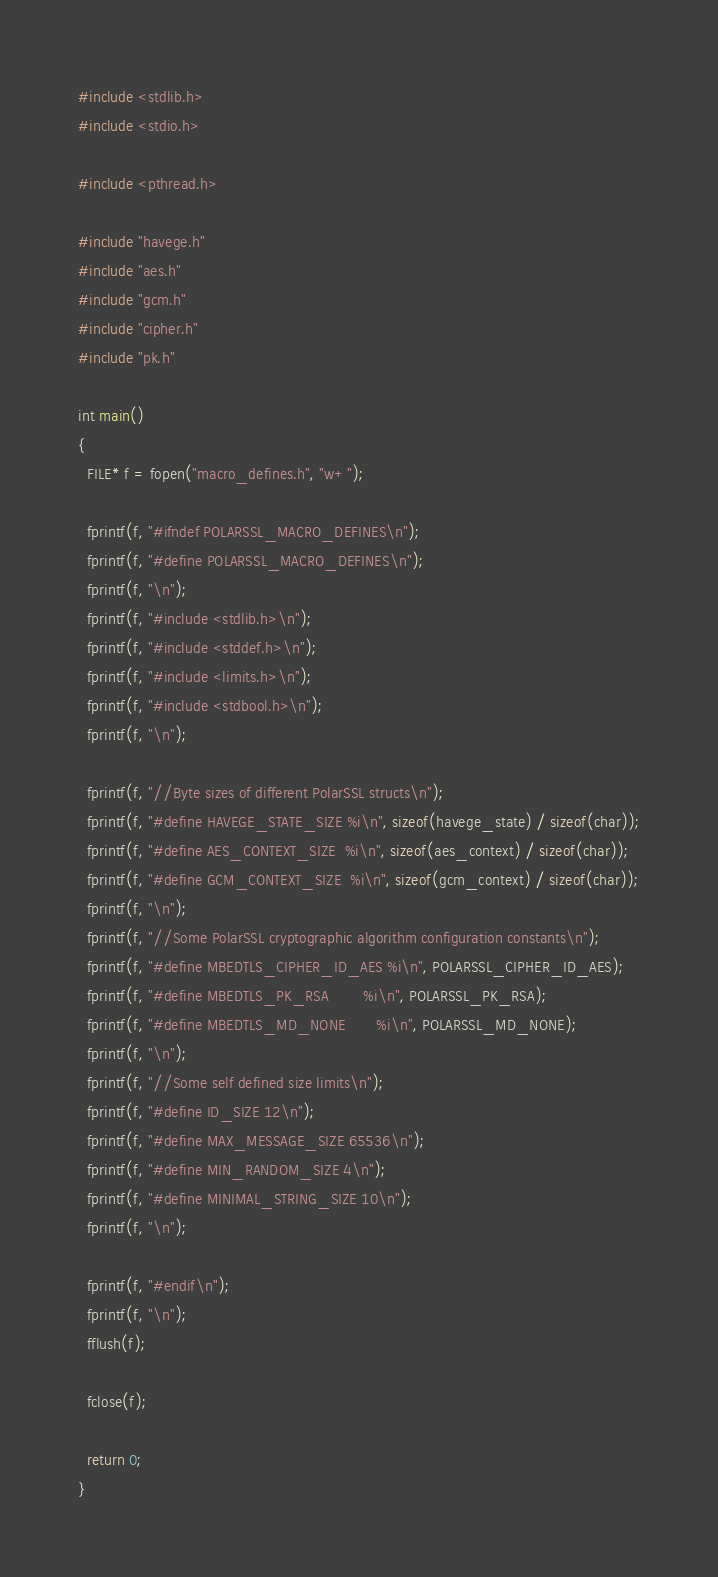Convert code to text. <code><loc_0><loc_0><loc_500><loc_500><_C_>#include <stdlib.h>
#include <stdio.h>

#include <pthread.h>

#include "havege.h"
#include "aes.h"
#include "gcm.h"
#include "cipher.h"
#include "pk.h"

int main()
{
  FILE* f = fopen("macro_defines.h", "w+");
  
  fprintf(f, "#ifndef POLARSSL_MACRO_DEFINES\n");
  fprintf(f, "#define POLARSSL_MACRO_DEFINES\n");
  fprintf(f, "\n");
  fprintf(f, "#include <stdlib.h>\n");
  fprintf(f, "#include <stddef.h>\n");
  fprintf(f, "#include <limits.h>\n");
  fprintf(f, "#include <stdbool.h>\n");
  fprintf(f, "\n");
  
  fprintf(f, "//Byte sizes of different PolarSSL structs\n");
  fprintf(f, "#define HAVEGE_STATE_SIZE %i\n", sizeof(havege_state) / sizeof(char));
  fprintf(f, "#define AES_CONTEXT_SIZE  %i\n", sizeof(aes_context) / sizeof(char));
  fprintf(f, "#define GCM_CONTEXT_SIZE  %i\n", sizeof(gcm_context) / sizeof(char));
  fprintf(f, "\n");
  fprintf(f, "//Some PolarSSL cryptographic algorithm configuration constants\n");
  fprintf(f, "#define MBEDTLS_CIPHER_ID_AES %i\n", POLARSSL_CIPHER_ID_AES);
  fprintf(f, "#define MBEDTLS_PK_RSA        %i\n", POLARSSL_PK_RSA);
  fprintf(f, "#define MBEDTLS_MD_NONE       %i\n", POLARSSL_MD_NONE);
  fprintf(f, "\n");
  fprintf(f, "//Some self defined size limits\n");
  fprintf(f, "#define ID_SIZE 12\n");
  fprintf(f, "#define MAX_MESSAGE_SIZE 65536\n");
  fprintf(f, "#define MIN_RANDOM_SIZE 4\n");
  fprintf(f, "#define MINIMAL_STRING_SIZE 10\n");
  fprintf(f, "\n");
  
  fprintf(f, "#endif\n");
  fprintf(f, "\n");
  fflush(f);
  
  fclose(f);
  
  return 0;
}
</code> 